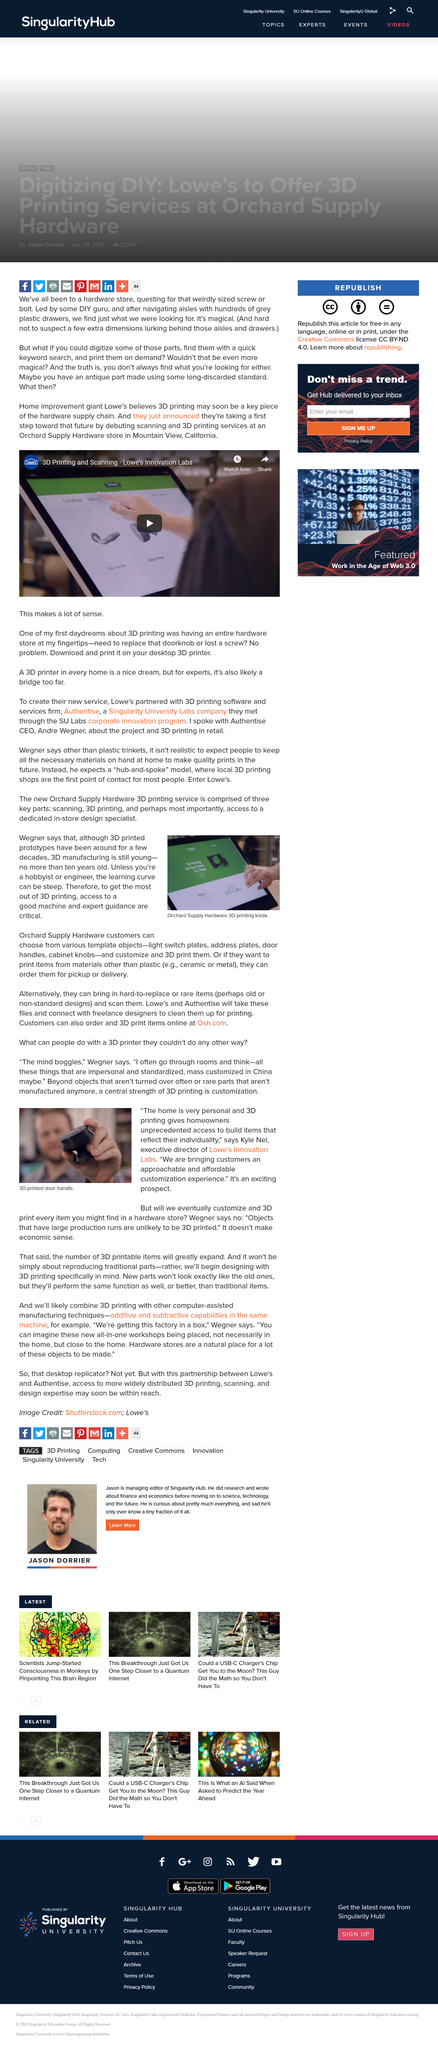List a handful of essential elements in this visual. Lowe's, a home improvement retailer, and Authentise, a software company, met through the SU Labs corporate innovation program. Andre Wegner is the CEO of Authentise. I, Kyle Nel, stated that 'the home is very personal.' In the photograph, a 3D printed door handle is visible. The executive director of Lowe's Innovation Labs is Kyle Nelson. 